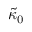Convert formula to latex. <formula><loc_0><loc_0><loc_500><loc_500>\tilde { \kappa } _ { 0 }</formula> 